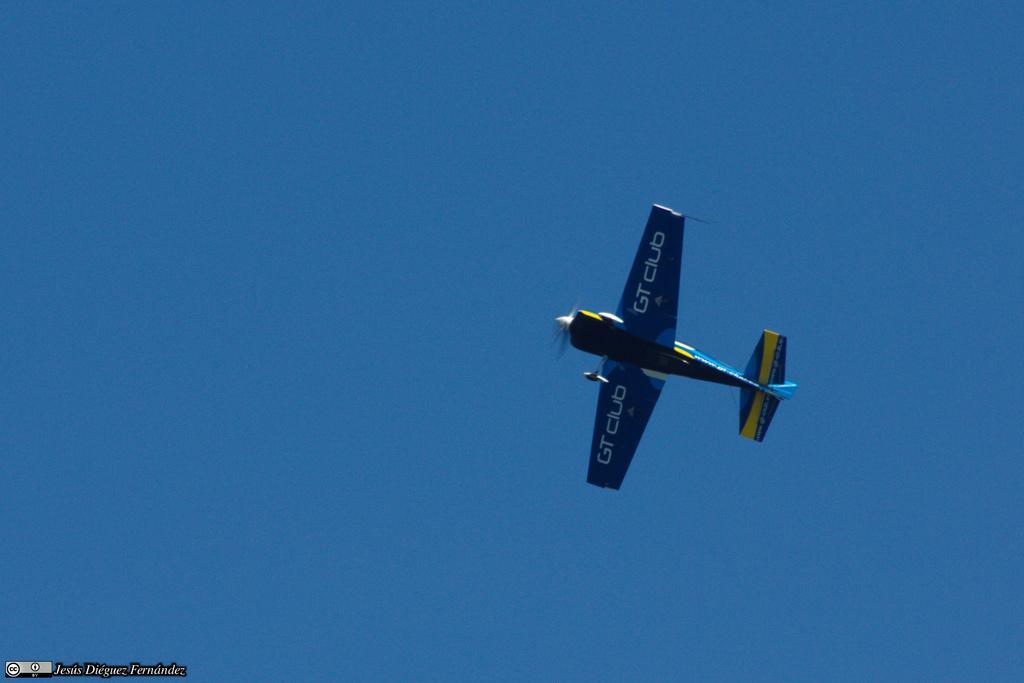Please provide a concise description of this image. Here in this picture we can see an airplane flying in the sky over there. 